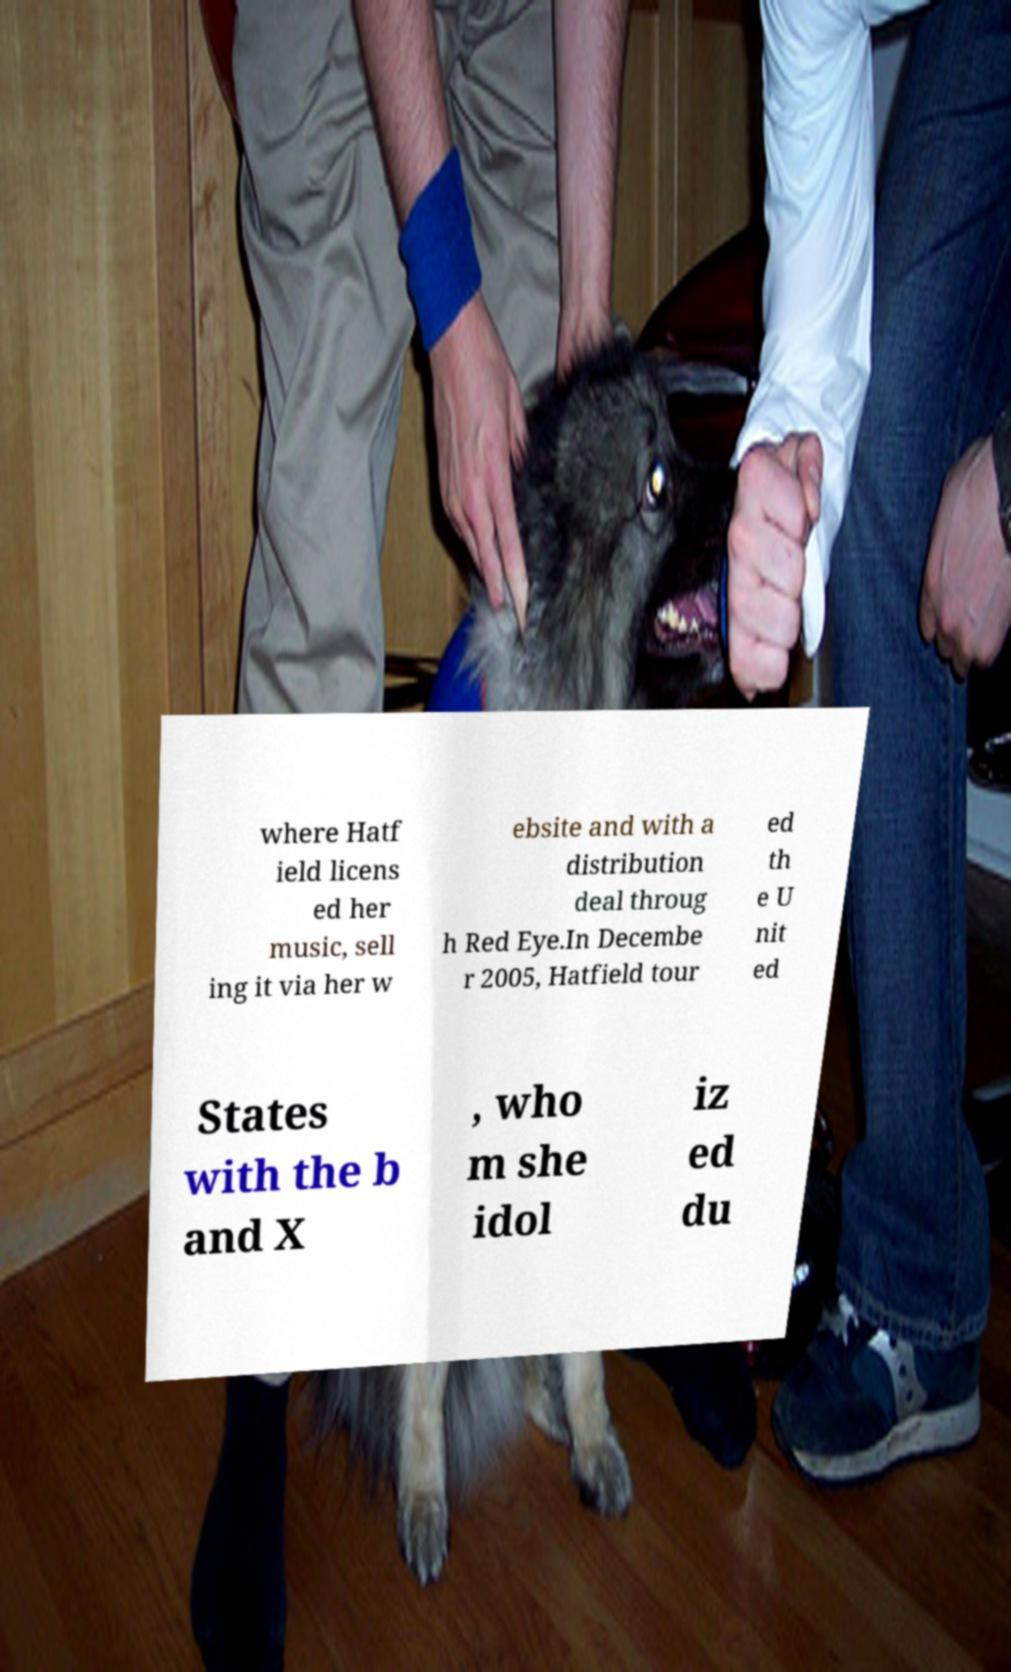Please read and relay the text visible in this image. What does it say? where Hatf ield licens ed her music, sell ing it via her w ebsite and with a distribution deal throug h Red Eye.In Decembe r 2005, Hatfield tour ed th e U nit ed States with the b and X , who m she idol iz ed du 